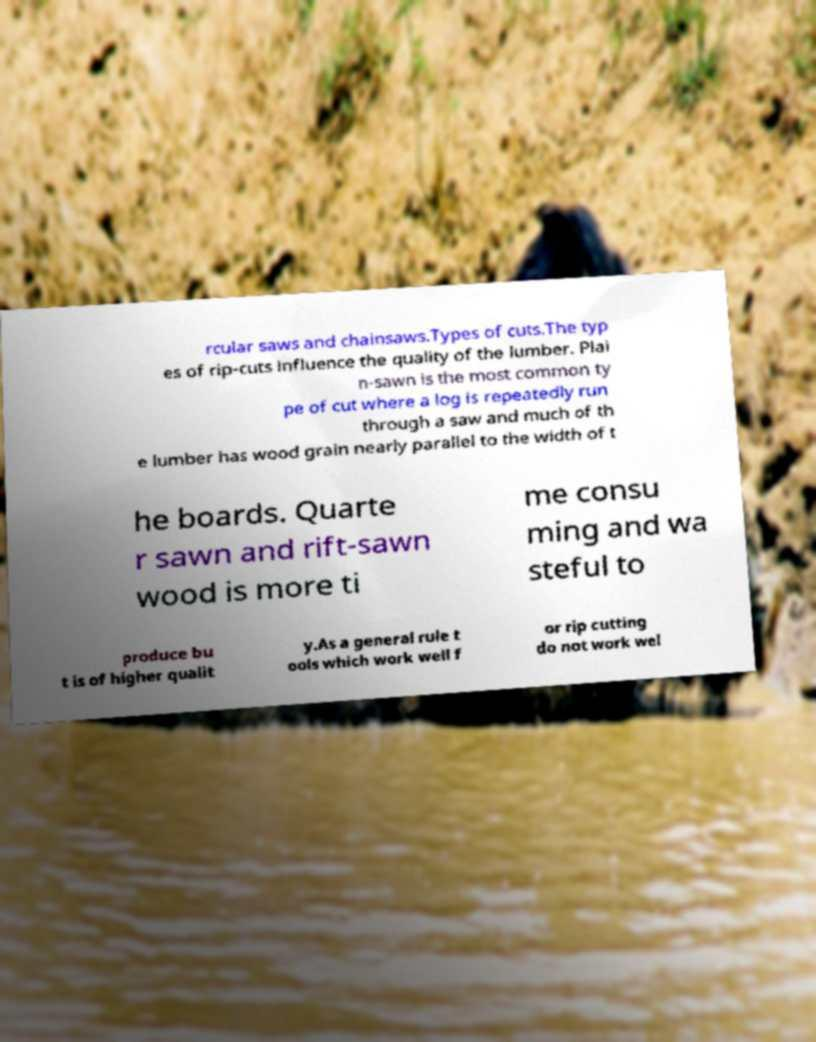Can you accurately transcribe the text from the provided image for me? rcular saws and chainsaws.Types of cuts.The typ es of rip-cuts influence the quality of the lumber. Plai n-sawn is the most common ty pe of cut where a log is repeatedly run through a saw and much of th e lumber has wood grain nearly parallel to the width of t he boards. Quarte r sawn and rift-sawn wood is more ti me consu ming and wa steful to produce bu t is of higher qualit y.As a general rule t ools which work well f or rip cutting do not work wel 